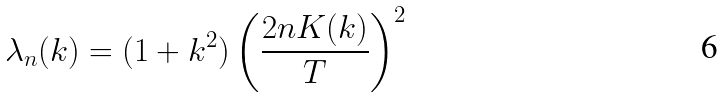<formula> <loc_0><loc_0><loc_500><loc_500>\lambda _ { n } ( k ) = ( 1 + k ^ { 2 } ) \left ( \frac { 2 n K ( k ) } { T } \right ) ^ { 2 }</formula> 